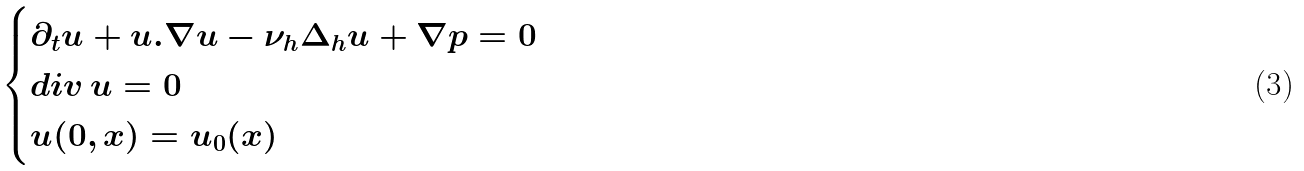Convert formula to latex. <formula><loc_0><loc_0><loc_500><loc_500>\begin{cases} \partial _ { t } u + u . \nabla u - \nu _ { h } \Delta _ { h } u + \nabla p = 0 \\ d i v \, u = 0 \\ u ( 0 , x ) = u _ { 0 } ( x ) \end{cases}</formula> 